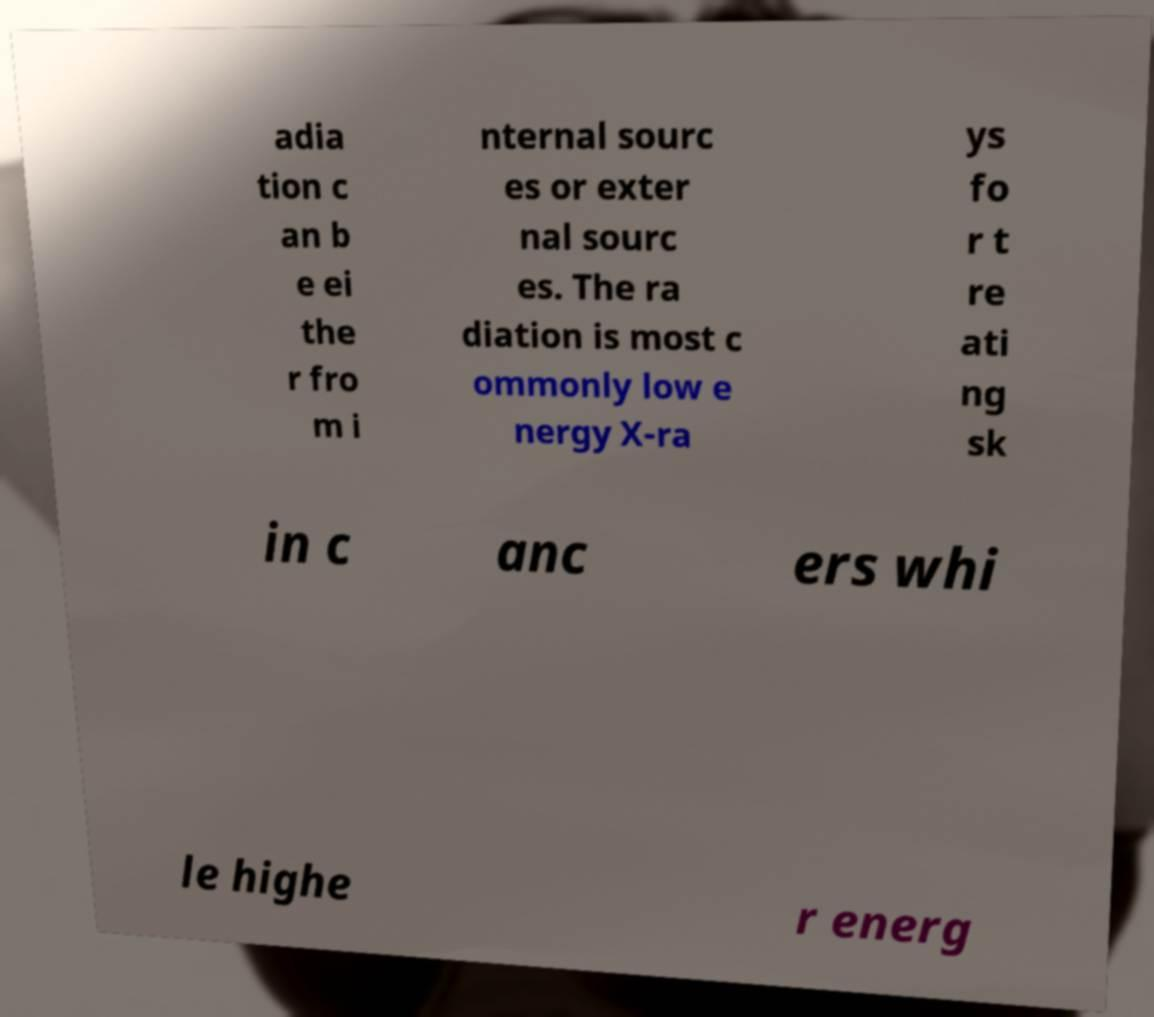Could you assist in decoding the text presented in this image and type it out clearly? adia tion c an b e ei the r fro m i nternal sourc es or exter nal sourc es. The ra diation is most c ommonly low e nergy X-ra ys fo r t re ati ng sk in c anc ers whi le highe r energ 